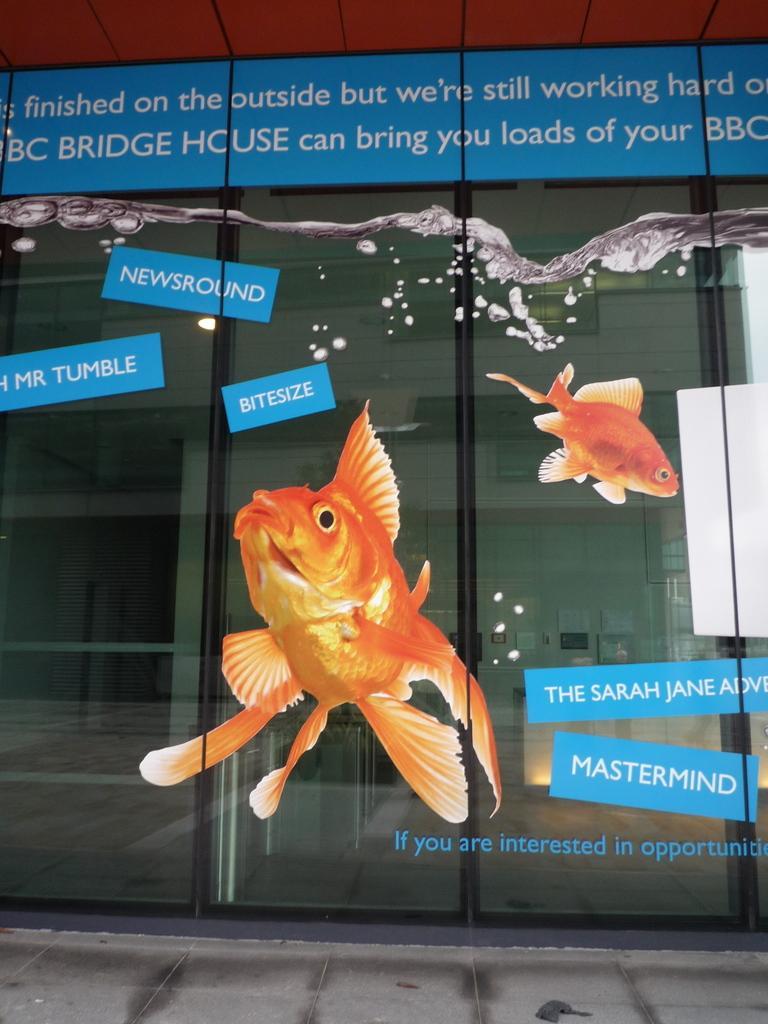Could you give a brief overview of what you see in this image? In this image in the center there is posters on the glass and there is some text written on it. 